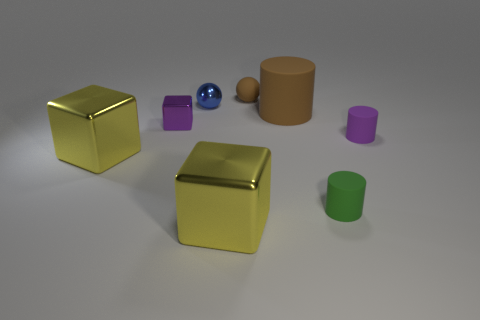What number of tiny blue objects have the same material as the small green thing?
Provide a succinct answer. 0. Are there any large purple matte cylinders?
Give a very brief answer. No. What number of small cubes have the same color as the matte sphere?
Ensure brevity in your answer.  0. Are the blue sphere and the brown thing that is in front of the tiny brown rubber sphere made of the same material?
Ensure brevity in your answer.  No. Is the number of purple things on the right side of the tiny green cylinder greater than the number of large metal cylinders?
Your response must be concise. Yes. There is a big rubber thing; is it the same color as the metallic cube to the right of the tiny blue ball?
Keep it short and to the point. No. Are there the same number of things that are behind the small blue object and brown things that are behind the brown rubber cylinder?
Offer a terse response. Yes. What material is the tiny object behind the tiny blue metal sphere?
Keep it short and to the point. Rubber. What number of things are big metal things to the left of the small shiny block or large green metal cubes?
Your answer should be very brief. 1. What number of other objects are there of the same shape as the purple matte object?
Ensure brevity in your answer.  2. 